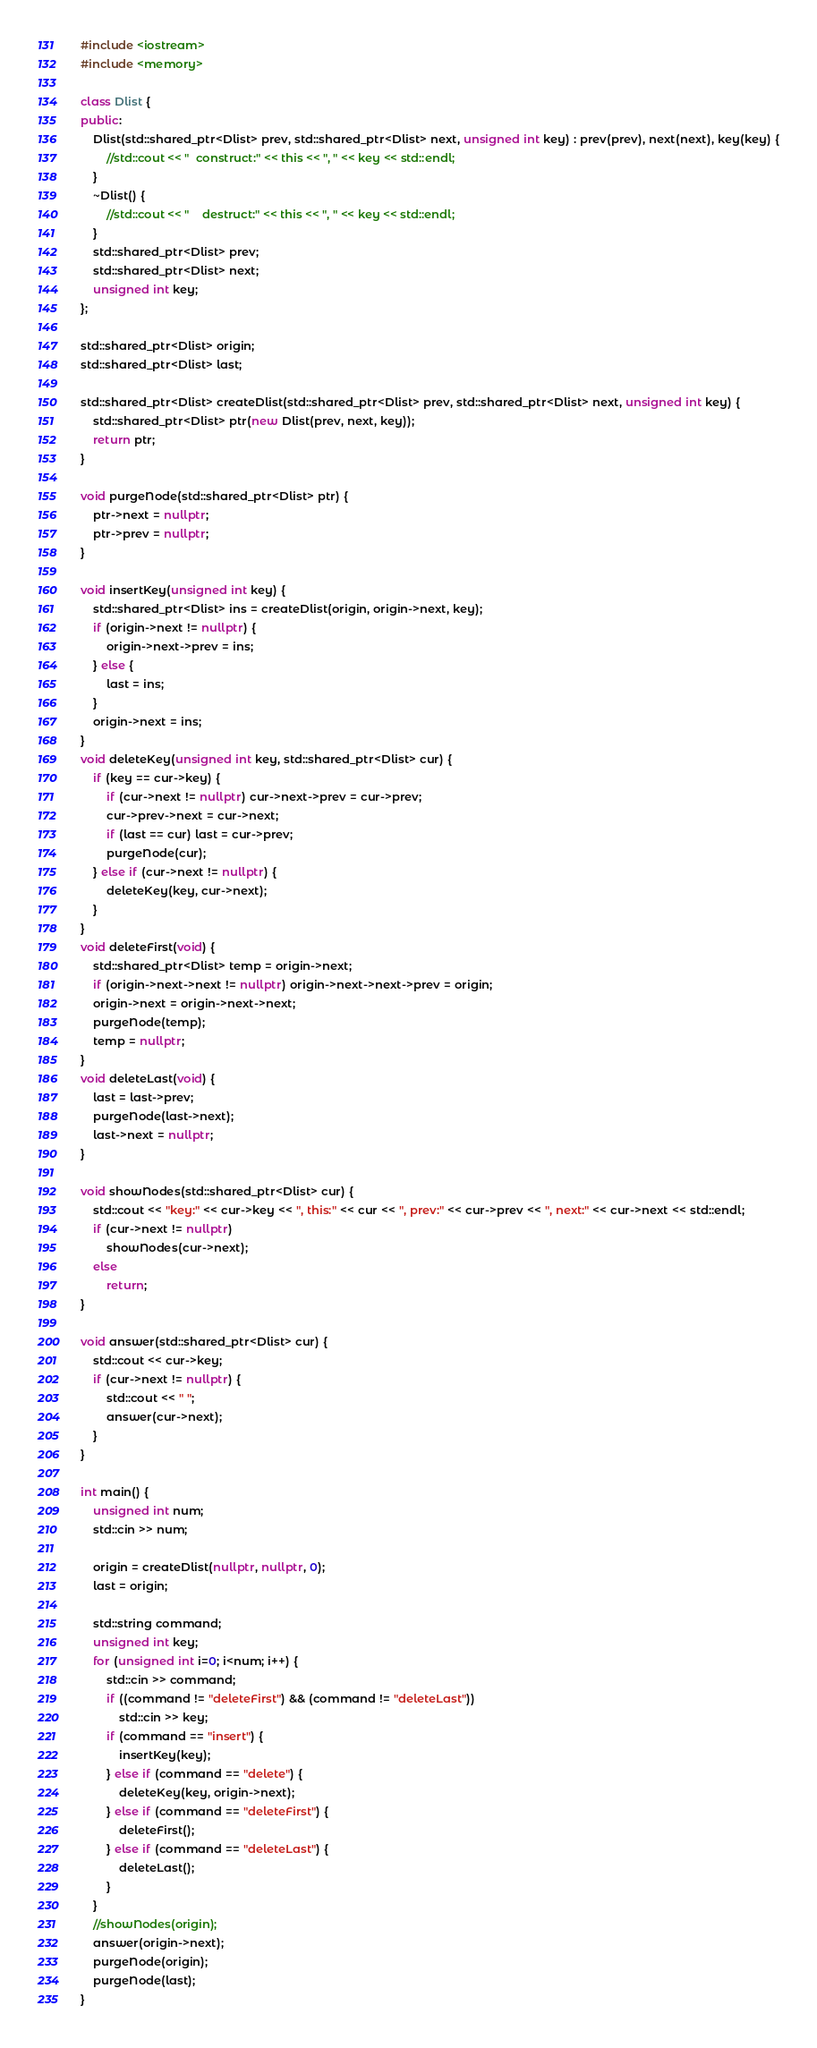Convert code to text. <code><loc_0><loc_0><loc_500><loc_500><_C++_>#include <iostream>
#include <memory>

class Dlist {
public:
    Dlist(std::shared_ptr<Dlist> prev, std::shared_ptr<Dlist> next, unsigned int key) : prev(prev), next(next), key(key) {
        //std::cout << "  construct:" << this << ", " << key << std::endl;
    }
    ~Dlist() {
        //std::cout << "    destruct:" << this << ", " << key << std::endl;
    }
    std::shared_ptr<Dlist> prev;
    std::shared_ptr<Dlist> next;
    unsigned int key;
};

std::shared_ptr<Dlist> origin;
std::shared_ptr<Dlist> last;

std::shared_ptr<Dlist> createDlist(std::shared_ptr<Dlist> prev, std::shared_ptr<Dlist> next, unsigned int key) {
    std::shared_ptr<Dlist> ptr(new Dlist(prev, next, key));
    return ptr;
}

void purgeNode(std::shared_ptr<Dlist> ptr) {
    ptr->next = nullptr;
    ptr->prev = nullptr;
}

void insertKey(unsigned int key) {
    std::shared_ptr<Dlist> ins = createDlist(origin, origin->next, key);
    if (origin->next != nullptr) {
        origin->next->prev = ins;
    } else {
        last = ins;
    }
    origin->next = ins;
}
void deleteKey(unsigned int key, std::shared_ptr<Dlist> cur) {
    if (key == cur->key) {
        if (cur->next != nullptr) cur->next->prev = cur->prev;
        cur->prev->next = cur->next;
        if (last == cur) last = cur->prev;
        purgeNode(cur);
    } else if (cur->next != nullptr) {
        deleteKey(key, cur->next);
    }
}
void deleteFirst(void) {
    std::shared_ptr<Dlist> temp = origin->next;
    if (origin->next->next != nullptr) origin->next->next->prev = origin;
    origin->next = origin->next->next;
    purgeNode(temp);
    temp = nullptr;
}
void deleteLast(void) {
    last = last->prev;
    purgeNode(last->next);
    last->next = nullptr;
}

void showNodes(std::shared_ptr<Dlist> cur) {
    std::cout << "key:" << cur->key << ", this:" << cur << ", prev:" << cur->prev << ", next:" << cur->next << std::endl;
    if (cur->next != nullptr)
        showNodes(cur->next);
    else
        return;
}

void answer(std::shared_ptr<Dlist> cur) {
    std::cout << cur->key;
    if (cur->next != nullptr) {
        std::cout << " ";
        answer(cur->next);
    }
}

int main() {
    unsigned int num;
    std::cin >> num;
    
    origin = createDlist(nullptr, nullptr, 0);
    last = origin;
    
    std::string command;
    unsigned int key;
    for (unsigned int i=0; i<num; i++) {
        std::cin >> command;
        if ((command != "deleteFirst") && (command != "deleteLast"))
            std::cin >> key;
        if (command == "insert") {
            insertKey(key);
        } else if (command == "delete") {
            deleteKey(key, origin->next);
        } else if (command == "deleteFirst") {
            deleteFirst();
        } else if (command == "deleteLast") {
            deleteLast();
        }
    }
    //showNodes(origin);
    answer(origin->next);
    purgeNode(origin);
    purgeNode(last);
}

</code> 